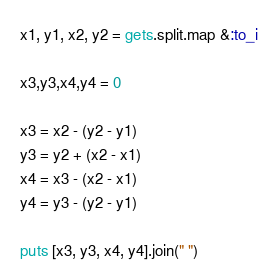Convert code to text. <code><loc_0><loc_0><loc_500><loc_500><_Ruby_>x1, y1, x2, y2 = gets.split.map &:to_i

x3,y3,x4,y4 = 0

x3 = x2 - (y2 - y1)
y3 = y2 + (x2 - x1)
x4 = x3 - (x2 - x1)
y4 = y3 - (y2 - y1)

puts [x3, y3, x4, y4].join(" ")</code> 